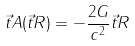Convert formula to latex. <formula><loc_0><loc_0><loc_500><loc_500>\vec { t } { A } ( \vec { t } { R } ) = - \frac { 2 G } { c ^ { 2 } } \vec { t } { R }</formula> 